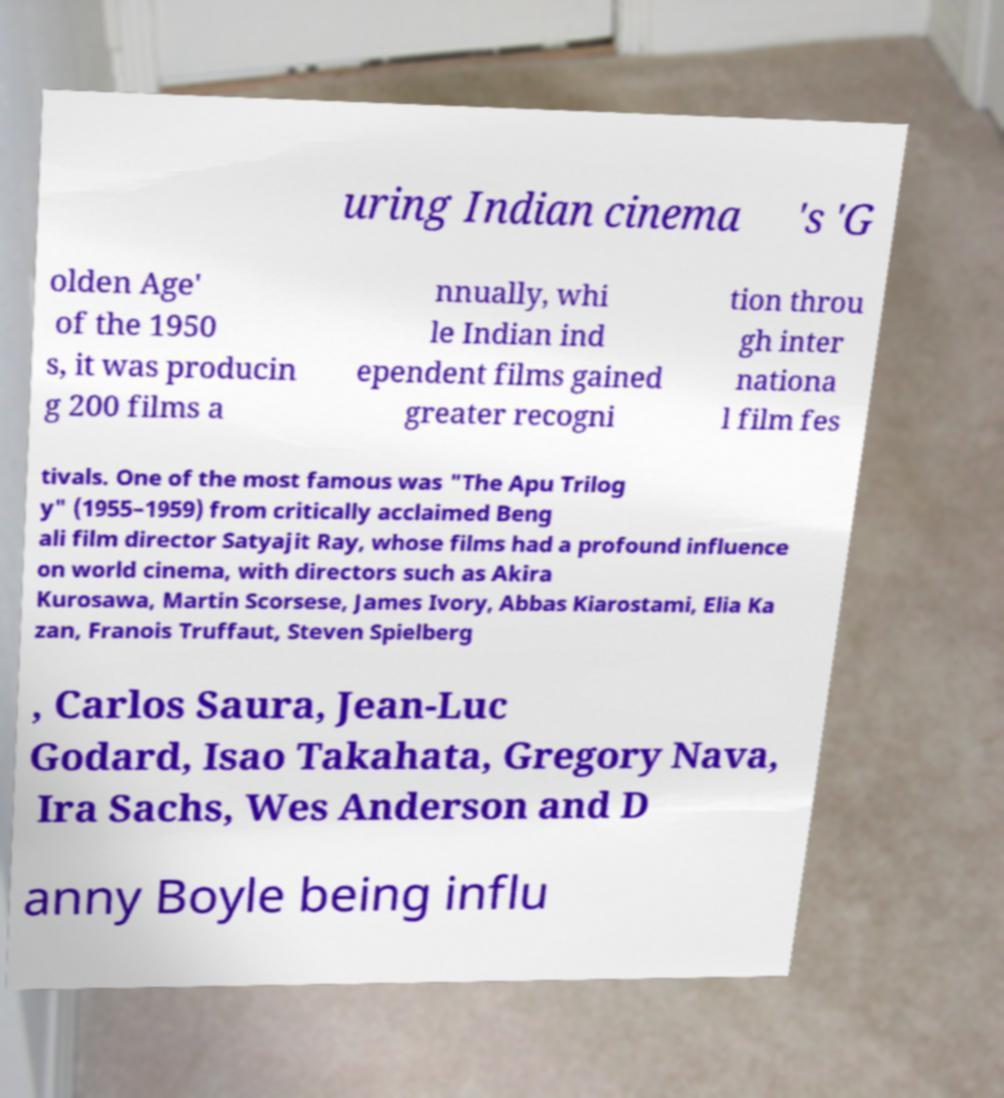For documentation purposes, I need the text within this image transcribed. Could you provide that? uring Indian cinema 's 'G olden Age' of the 1950 s, it was producin g 200 films a nnually, whi le Indian ind ependent films gained greater recogni tion throu gh inter nationa l film fes tivals. One of the most famous was "The Apu Trilog y" (1955–1959) from critically acclaimed Beng ali film director Satyajit Ray, whose films had a profound influence on world cinema, with directors such as Akira Kurosawa, Martin Scorsese, James Ivory, Abbas Kiarostami, Elia Ka zan, Franois Truffaut, Steven Spielberg , Carlos Saura, Jean-Luc Godard, Isao Takahata, Gregory Nava, Ira Sachs, Wes Anderson and D anny Boyle being influ 